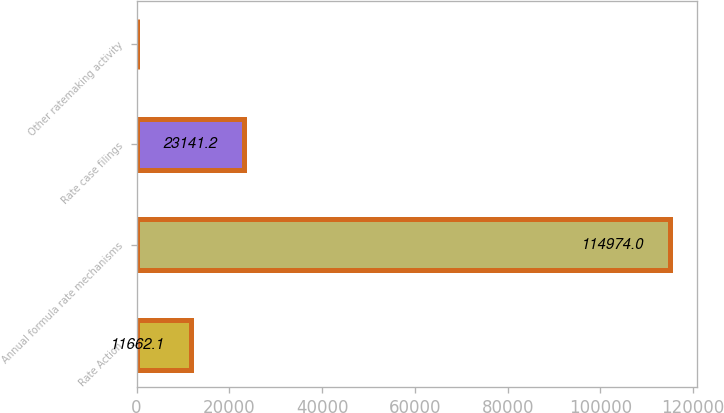Convert chart. <chart><loc_0><loc_0><loc_500><loc_500><bar_chart><fcel>Rate Action<fcel>Annual formula rate mechanisms<fcel>Rate case filings<fcel>Other ratemaking activity<nl><fcel>11662.1<fcel>114974<fcel>23141.2<fcel>183<nl></chart> 